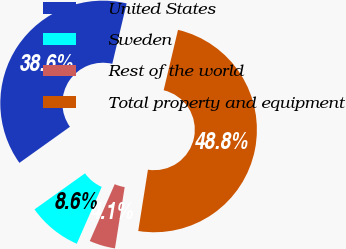Convert chart to OTSL. <chart><loc_0><loc_0><loc_500><loc_500><pie_chart><fcel>United States<fcel>Sweden<fcel>Rest of the world<fcel>Total property and equipment<nl><fcel>38.58%<fcel>8.55%<fcel>4.08%<fcel>48.78%<nl></chart> 